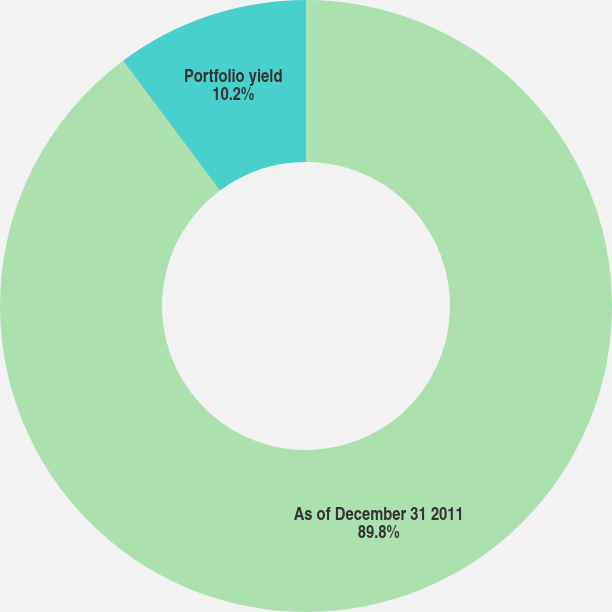Convert chart. <chart><loc_0><loc_0><loc_500><loc_500><pie_chart><fcel>As of December 31 2011<fcel>Portfolio yield<nl><fcel>89.8%<fcel>10.2%<nl></chart> 